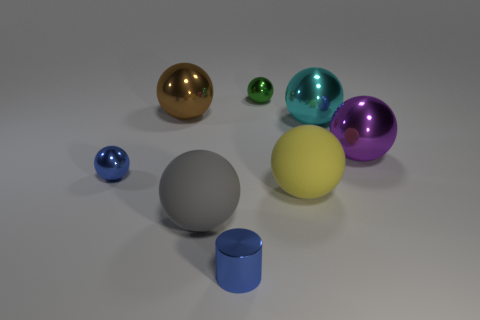What number of cyan things are either small metal cylinders or metallic objects?
Make the answer very short. 1. What number of other objects are the same size as the blue shiny cylinder?
Make the answer very short. 2. How many big brown objects are there?
Your response must be concise. 1. Is there any other thing that is the same shape as the cyan metallic thing?
Offer a terse response. Yes. Does the gray object on the left side of the large purple metal thing have the same material as the tiny sphere that is to the left of the small green metallic sphere?
Your response must be concise. No. What material is the big purple thing?
Make the answer very short. Metal. What number of big yellow things have the same material as the big brown sphere?
Your answer should be very brief. 0. How many metal objects are either large brown balls or large cyan objects?
Offer a very short reply. 2. There is a small blue thing on the right side of the large brown ball; is its shape the same as the big metal object that is behind the cyan shiny object?
Offer a very short reply. No. There is a thing that is both right of the gray ball and in front of the large yellow rubber sphere; what color is it?
Offer a very short reply. Blue. 